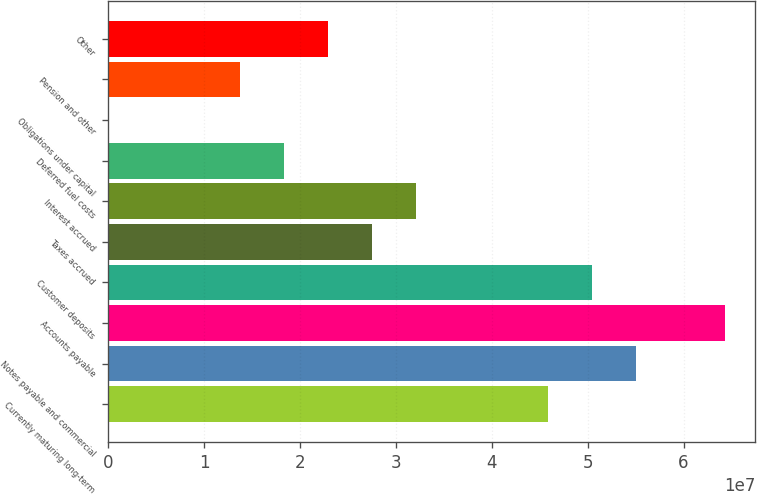<chart> <loc_0><loc_0><loc_500><loc_500><bar_chart><fcel>Currently maturing long-term<fcel>Notes payable and commercial<fcel>Accounts payable<fcel>Customer deposits<fcel>Taxes accrued<fcel>Interest accrued<fcel>Deferred fuel costs<fcel>Obligations under capital<fcel>Pension and other<fcel>Other<nl><fcel>4.59044e+07<fcel>5.50848e+07<fcel>6.42652e+07<fcel>5.04946e+07<fcel>2.75436e+07<fcel>3.21338e+07<fcel>1.83632e+07<fcel>2423<fcel>1.3773e+07<fcel>2.29534e+07<nl></chart> 